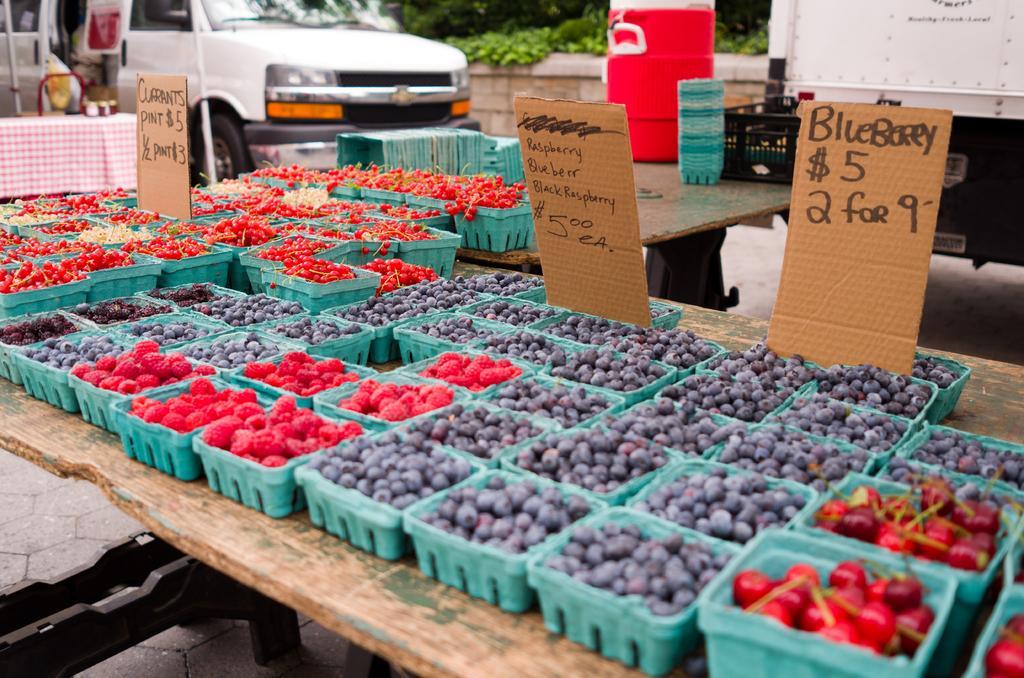Please provide a concise description of this image. In this image there are wooden tables. On tables there are baskets. In the baskets there are cherries, raspberries and blueberries. Beside the baskets there are small boards with text. In the background there is a vehicle and plants. 